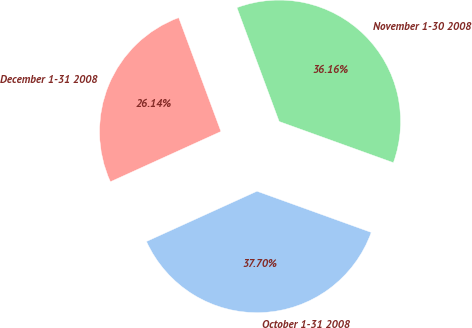Convert chart to OTSL. <chart><loc_0><loc_0><loc_500><loc_500><pie_chart><fcel>October 1-31 2008<fcel>November 1-30 2008<fcel>December 1-31 2008<nl><fcel>37.7%<fcel>36.16%<fcel>26.14%<nl></chart> 